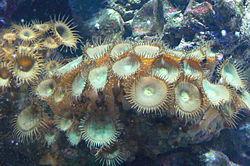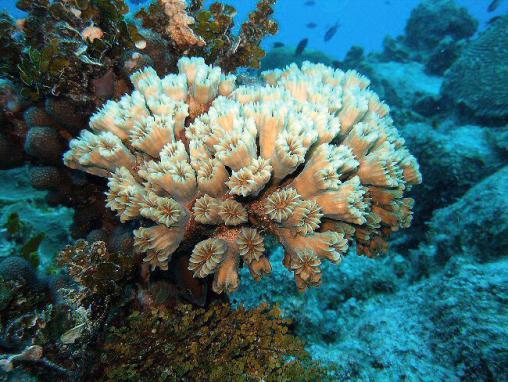The first image is the image on the left, the second image is the image on the right. Analyze the images presented: Is the assertion "One image shows a mass of flower-shaped anemone with flatter white centers surrounded by slender tendrils." valid? Answer yes or no. Yes. The first image is the image on the left, the second image is the image on the right. For the images displayed, is the sentence "IN at least one image there is at least 10 circled yellow and brown corral  arms facing forward." factually correct? Answer yes or no. Yes. 